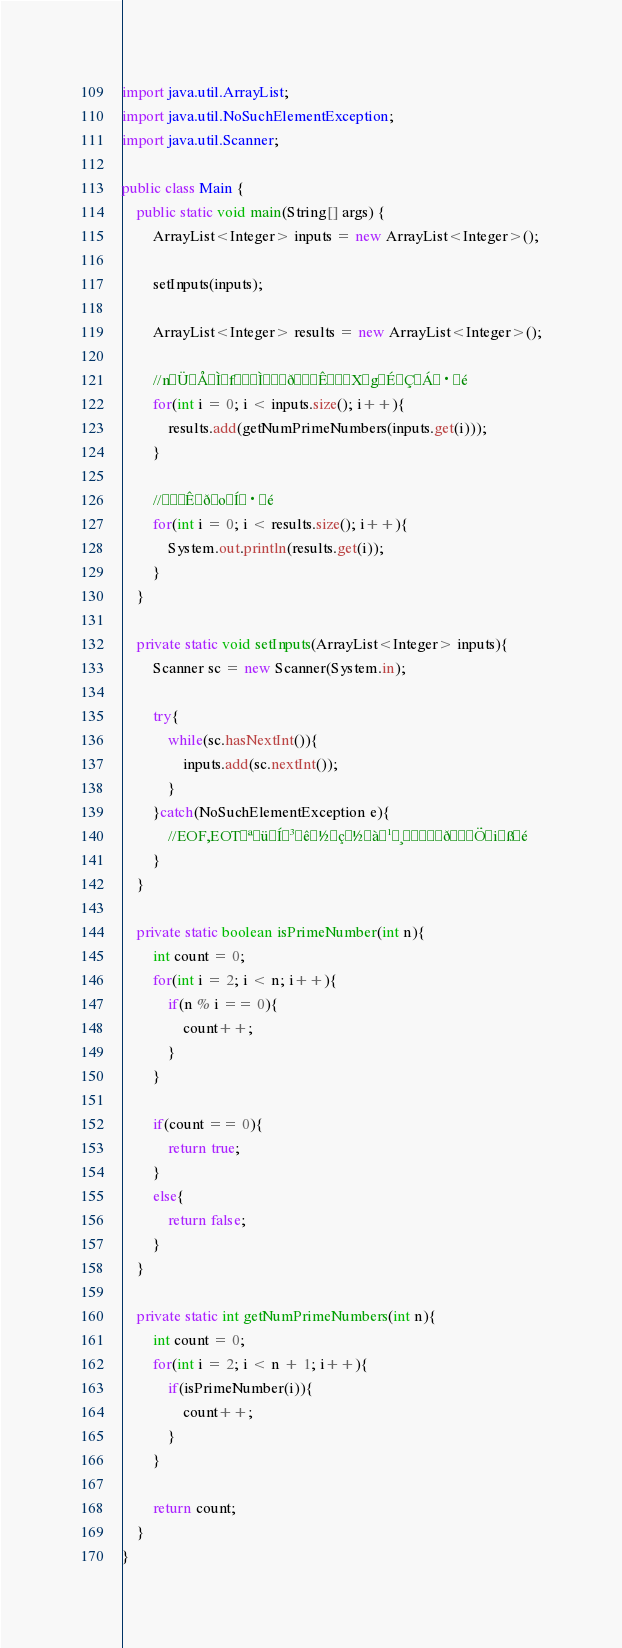<code> <loc_0><loc_0><loc_500><loc_500><_Java_>
import java.util.ArrayList;
import java.util.NoSuchElementException;
import java.util.Scanner;

public class Main {
	public static void main(String[] args) {
		ArrayList<Integer> inputs = new ArrayList<Integer>();
		
		setInputs(inputs);
		
		ArrayList<Integer> results = new ArrayList<Integer>();
		
		//nÜÅÌfÌðÊXgÉÇÁ·é
		for(int i = 0; i < inputs.size(); i++){
			results.add(getNumPrimeNumbers(inputs.get(i)));
		}
		
		//ÊðoÍ·é
		for(int i = 0; i < results.size(); i++){
			System.out.println(results.get(i));
		}
	}
	
	private static void setInputs(ArrayList<Integer> inputs){
		Scanner sc = new Scanner(System.in);
		
		try{
			while(sc.hasNextInt()){
				inputs.add(sc.nextInt());
			}
		}catch(NoSuchElementException e){
			//EOF,EOTªüÍ³ê½ç½à¹¸ðÖißé
		}
	}
	
	private static boolean isPrimeNumber(int n){
		int count = 0;
		for(int i = 2; i < n; i++){
			if(n % i == 0){
				count++;
			}
		}
		
		if(count == 0){
			return true;
		}
		else{
			return false;
		}
	}
	
	private static int getNumPrimeNumbers(int n){
		int count = 0;
		for(int i = 2; i < n + 1; i++){
			if(isPrimeNumber(i)){
				count++;
			}
		}
		
		return count;
	}
}</code> 